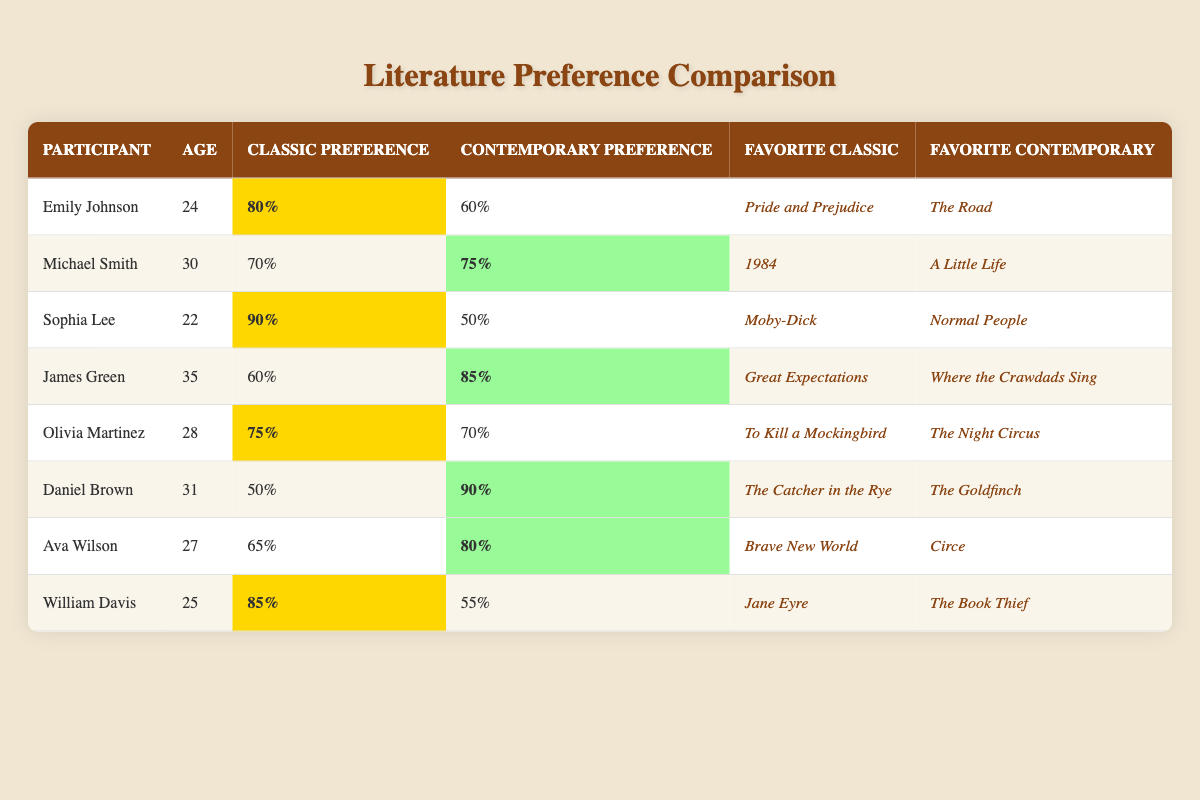What is the highest classic literature preference among the participants? By looking at the "Classic Preference" column, the highest value is 90%, which corresponds to Sophia Lee.
Answer: 90% Who has the lowest contemporary literature preference? Looking at the "Contemporary Preference" column, the lowest value is 50%, which belongs to Sophia Lee.
Answer: 50% Which participant prefers contemporary literature more than classic literature? By comparing the values in the "Classic Preference" and "Contemporary Preference" columns, Daniel Brown (90% vs. 50%), James Green (85% vs. 60%), and Ava Wilson (80% vs. 65%) have higher contemporary preferences.
Answer: Daniel Brown, James Green, Ava Wilson What is the average classic literature preference of all participants? The classic preferences are 80, 70, 90, 60, 75, 50, 65, and 85. Summing these gives 80 + 70 + 90 + 60 + 75 + 50 + 65 + 85 = 675. There are 8 participants, so the average is 675/8 = 84.375.
Answer: 84.375 Is there a participant who equally prefers classic and contemporary literature? Analyzing the "Classic Preference" and "Contemporary Preference" values, none of the participants have equal preferences, as all values are different.
Answer: No Which participant has the largest difference between their contemporary and classic preferences? The differences are calculated: Emily Johnson (20), Michael Smith (5), Sophia Lee (40), James Green (25), Olivia Martinez (5), Daniel Brown (40), Ava Wilson (15), and William Davis (30). The largest differences are 40% (Sophia Lee and Daniel Brown).
Answer: 40% (Sophia Lee and Daniel Brown) How many participants have a classic preference higher than 75%? Checking the "Classic Preference" column, Emily Johnson (80%), Sophia Lee (90%), Olivia Martinez (75%), and William Davis (85%) all have preferences higher than 75%, totaling 4 participants.
Answer: 4 Which contemporary book is favored by James Green? Referring to the "Favorite Contemporary" column, James Green's favorite contemporary book is "Where the Crawdads Sing."
Answer: Where the Crawdads Sing What is the median classic preference of the participants? Arranging the classic preferences (50, 60, 65, 70, 75, 80, 85, 90) and finding the median involves taking the average of the 4th and 5th values (70 and 75), so (70+75)/2 = 72.5.
Answer: 72.5 